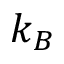Convert formula to latex. <formula><loc_0><loc_0><loc_500><loc_500>k _ { B }</formula> 